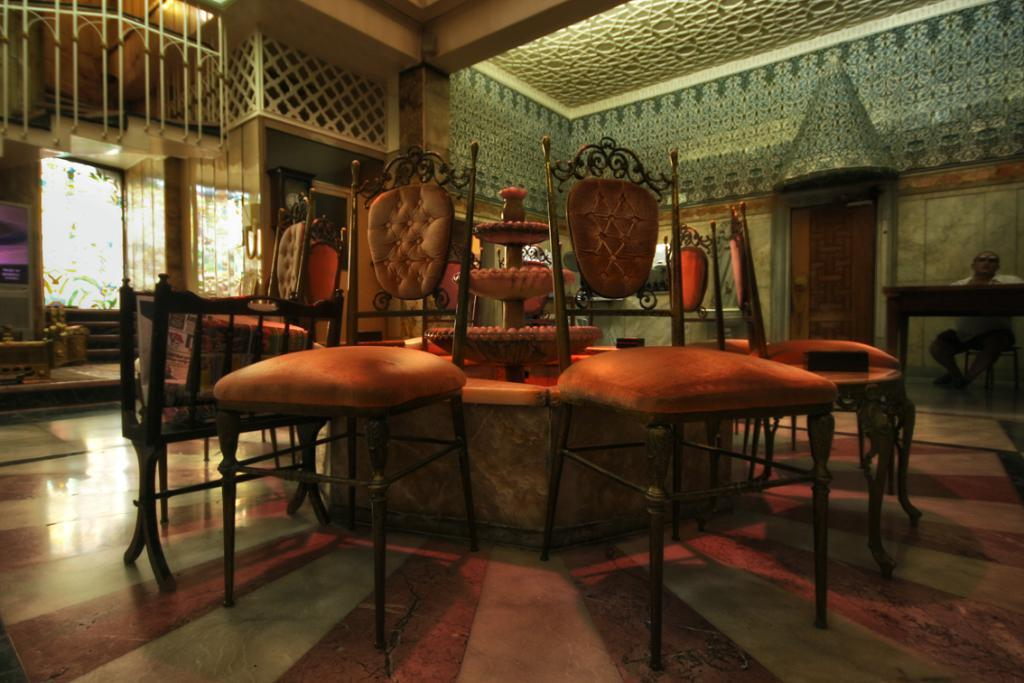What type of furniture is present in the room? There are chairs in the room. What is a unique feature in the room? There is a fountain in the room. Where is the person sitting in the image? The person is sitting on the right side of the image. What is in front of the person? There is a table in front of the person. How can natural light enter the room? There is a window in the room. What architectural feature is on the left side of the image? There are stairs on the left side of the image. What type of throat-soothing paste can be seen on the table in the image? There is no throat-soothing paste present in the image. What color is the sheet draped over the fountain in the image? There is no sheet draped over the fountain in the image. 